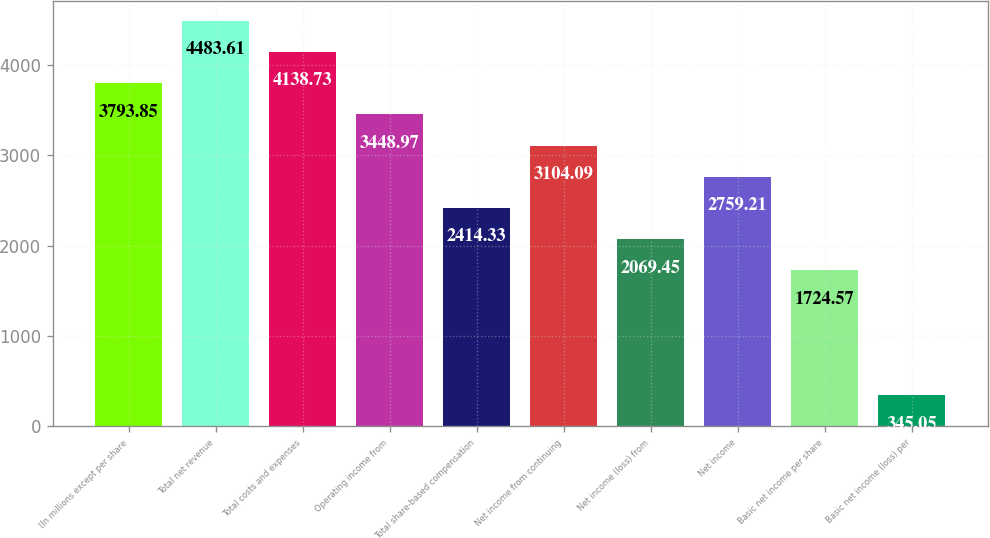Convert chart to OTSL. <chart><loc_0><loc_0><loc_500><loc_500><bar_chart><fcel>(In millions except per share<fcel>Total net revenue<fcel>Total costs and expenses<fcel>Operating income from<fcel>Total share-based compensation<fcel>Net income from continuing<fcel>Net income (loss) from<fcel>Net income<fcel>Basic net income per share<fcel>Basic net income (loss) per<nl><fcel>3793.85<fcel>4483.61<fcel>4138.73<fcel>3448.97<fcel>2414.33<fcel>3104.09<fcel>2069.45<fcel>2759.21<fcel>1724.57<fcel>345.05<nl></chart> 